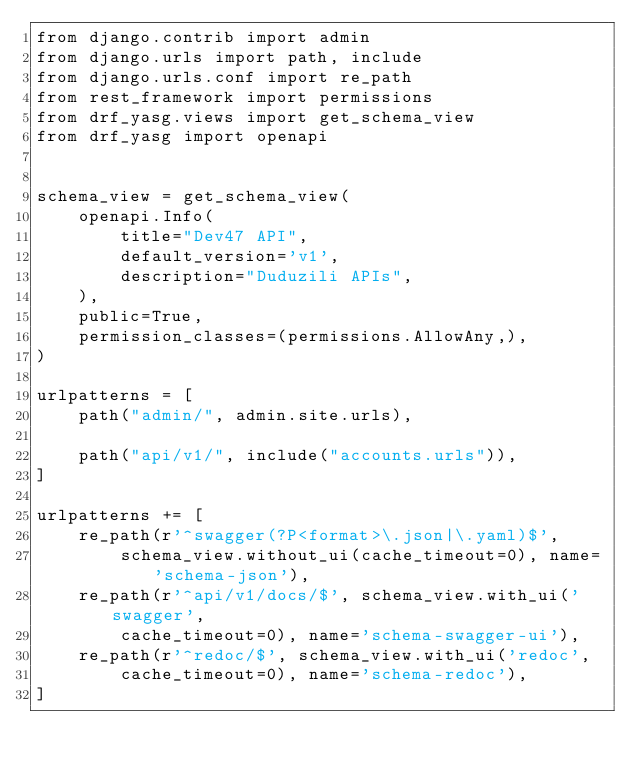<code> <loc_0><loc_0><loc_500><loc_500><_Python_>from django.contrib import admin
from django.urls import path, include
from django.urls.conf import re_path
from rest_framework import permissions
from drf_yasg.views import get_schema_view
from drf_yasg import openapi


schema_view = get_schema_view(
    openapi.Info(
        title="Dev47 API",
        default_version='v1',
        description="Duduzili APIs",
    ),
    public=True,
    permission_classes=(permissions.AllowAny,),
)

urlpatterns = [
    path("admin/", admin.site.urls),

    path("api/v1/", include("accounts.urls")),
]

urlpatterns += [
    re_path(r'^swagger(?P<format>\.json|\.yaml)$',
        schema_view.without_ui(cache_timeout=0), name='schema-json'),
    re_path(r'^api/v1/docs/$', schema_view.with_ui('swagger',
        cache_timeout=0), name='schema-swagger-ui'),
    re_path(r'^redoc/$', schema_view.with_ui('redoc',
        cache_timeout=0), name='schema-redoc'),
]
</code> 